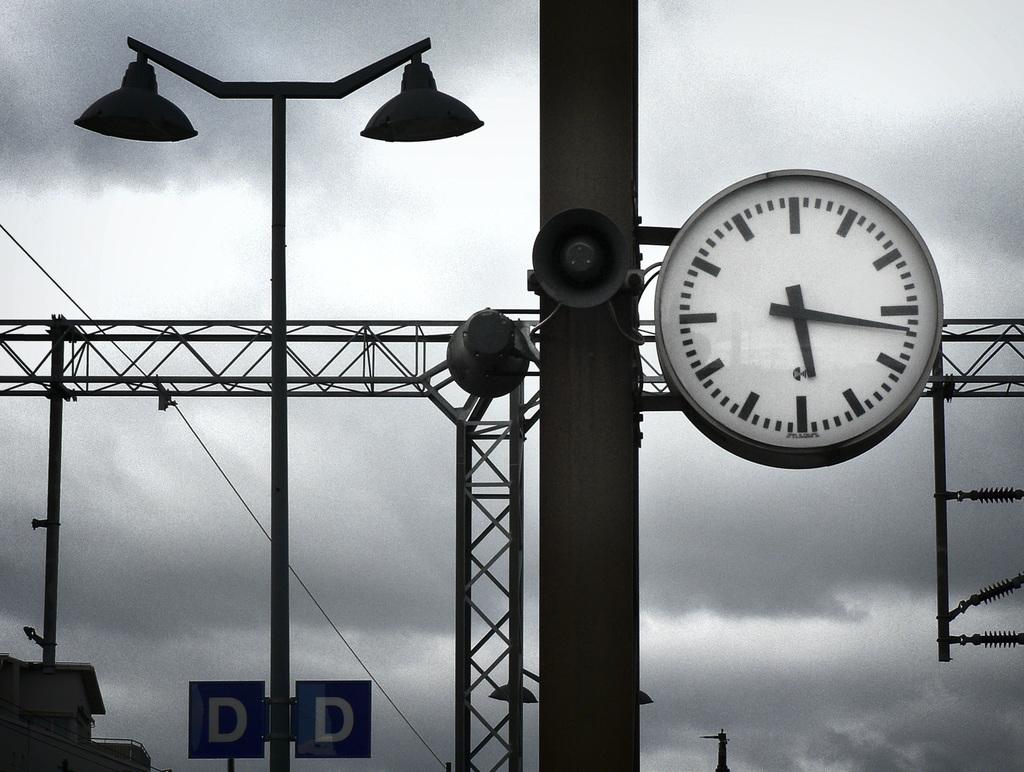What letter is on the sign on the lamppost?
Your response must be concise. D. 